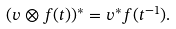<formula> <loc_0><loc_0><loc_500><loc_500>( v \otimes f ( t ) ) ^ { * } = v ^ { * } f ( t ^ { - 1 } ) .</formula> 